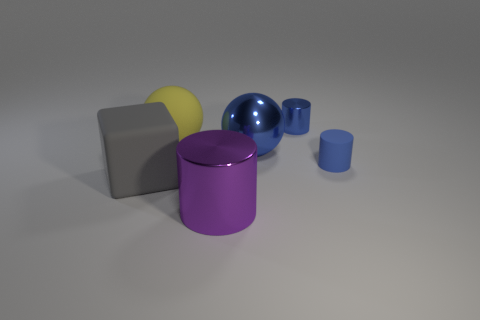Subtract all blue cylinders. How many were subtracted if there are1blue cylinders left? 1 Add 2 small brown shiny spheres. How many objects exist? 8 Subtract all cubes. How many objects are left? 5 Subtract all matte cylinders. Subtract all large green cylinders. How many objects are left? 5 Add 5 small blue things. How many small blue things are left? 7 Add 3 gray matte things. How many gray matte things exist? 4 Subtract 0 blue cubes. How many objects are left? 6 